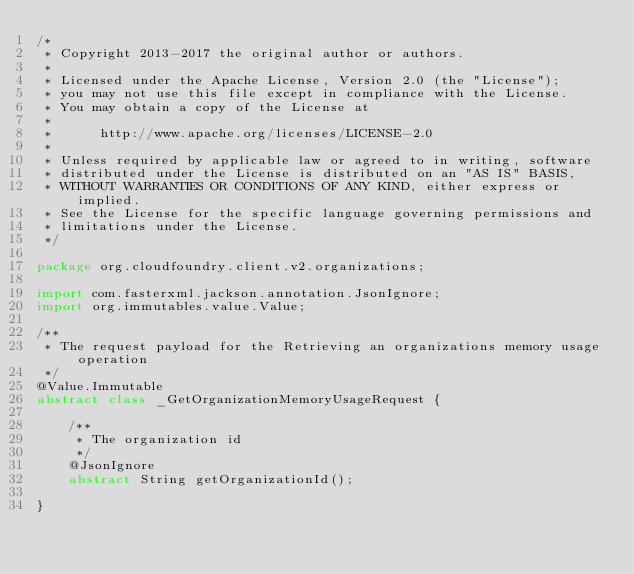Convert code to text. <code><loc_0><loc_0><loc_500><loc_500><_Java_>/*
 * Copyright 2013-2017 the original author or authors.
 *
 * Licensed under the Apache License, Version 2.0 (the "License");
 * you may not use this file except in compliance with the License.
 * You may obtain a copy of the License at
 *
 *      http://www.apache.org/licenses/LICENSE-2.0
 *
 * Unless required by applicable law or agreed to in writing, software
 * distributed under the License is distributed on an "AS IS" BASIS,
 * WITHOUT WARRANTIES OR CONDITIONS OF ANY KIND, either express or implied.
 * See the License for the specific language governing permissions and
 * limitations under the License.
 */

package org.cloudfoundry.client.v2.organizations;

import com.fasterxml.jackson.annotation.JsonIgnore;
import org.immutables.value.Value;

/**
 * The request payload for the Retrieving an organizations memory usage operation
 */
@Value.Immutable
abstract class _GetOrganizationMemoryUsageRequest {

    /**
     * The organization id
     */
    @JsonIgnore
    abstract String getOrganizationId();

}
</code> 